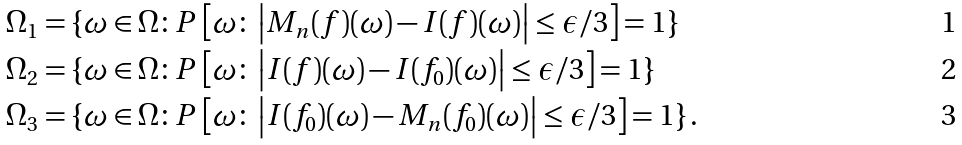<formula> <loc_0><loc_0><loc_500><loc_500>\Omega _ { 1 } & = \{ \omega \in \Omega \colon P \left [ \omega \colon \left | M _ { n } ( f ) ( \omega ) - I ( f ) ( \omega ) \right | \leq \epsilon / 3 \right ] = 1 \} \\ \Omega _ { 2 } & = \{ \omega \in \Omega \colon P \left [ \omega \colon \left | I ( f ) ( \omega ) - I ( f _ { 0 } ) ( \omega ) \right | \leq \epsilon / 3 \right ] = 1 \} \\ \Omega _ { 3 } & = \{ \omega \in \Omega \colon P \left [ \omega \colon \left | I ( f _ { 0 } ) ( \omega ) - M _ { n } ( f _ { 0 } ) ( \omega ) \right | \leq \epsilon / 3 \right ] = 1 \} \, .</formula> 